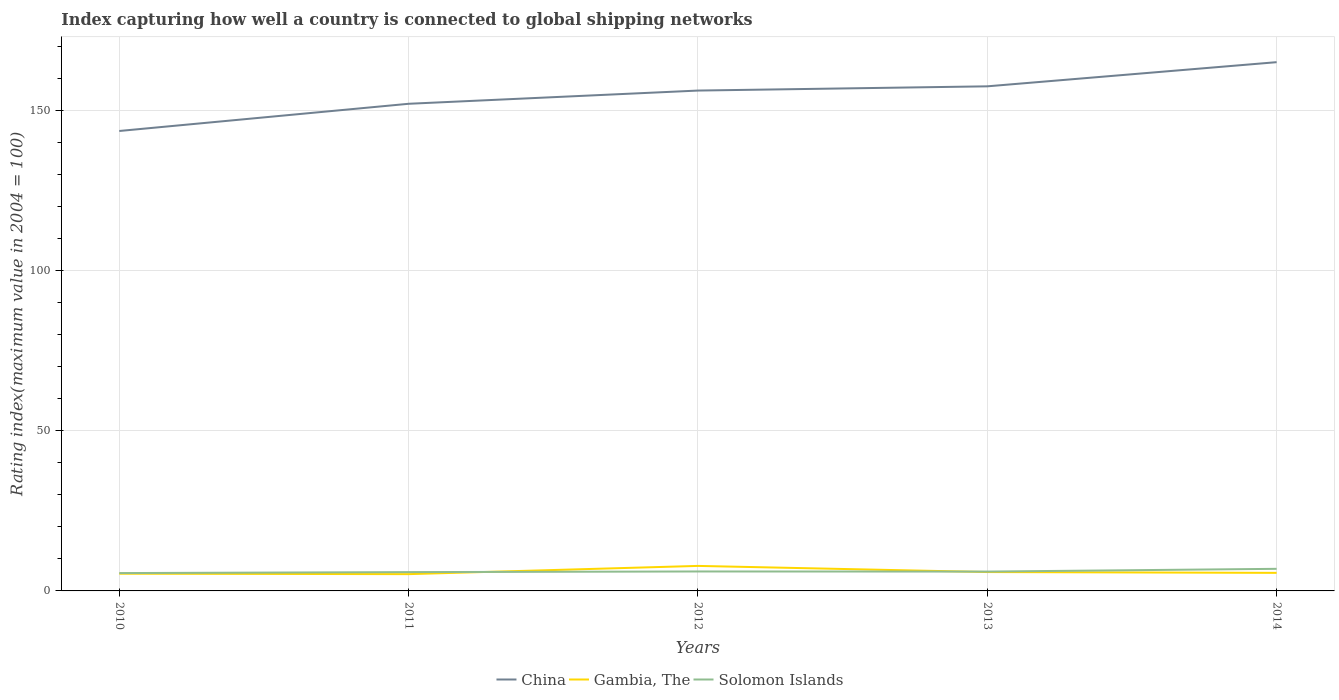How many different coloured lines are there?
Your answer should be very brief. 3. Across all years, what is the maximum rating index in Gambia, The?
Make the answer very short. 5.24. What is the total rating index in China in the graph?
Keep it short and to the point. -13.94. What is the difference between the highest and the second highest rating index in Gambia, The?
Provide a short and direct response. 2.57. Is the rating index in Solomon Islands strictly greater than the rating index in China over the years?
Your answer should be compact. Yes. How many lines are there?
Keep it short and to the point. 3. What is the difference between two consecutive major ticks on the Y-axis?
Make the answer very short. 50. Where does the legend appear in the graph?
Offer a very short reply. Bottom center. How many legend labels are there?
Give a very brief answer. 3. How are the legend labels stacked?
Your answer should be very brief. Horizontal. What is the title of the graph?
Make the answer very short. Index capturing how well a country is connected to global shipping networks. What is the label or title of the X-axis?
Make the answer very short. Years. What is the label or title of the Y-axis?
Keep it short and to the point. Rating index(maximum value in 2004 = 100). What is the Rating index(maximum value in 2004 = 100) of China in 2010?
Keep it short and to the point. 143.57. What is the Rating index(maximum value in 2004 = 100) in Gambia, The in 2010?
Your response must be concise. 5.38. What is the Rating index(maximum value in 2004 = 100) in Solomon Islands in 2010?
Ensure brevity in your answer.  5.57. What is the Rating index(maximum value in 2004 = 100) in China in 2011?
Your answer should be very brief. 152.06. What is the Rating index(maximum value in 2004 = 100) in Gambia, The in 2011?
Provide a succinct answer. 5.24. What is the Rating index(maximum value in 2004 = 100) in Solomon Islands in 2011?
Keep it short and to the point. 5.87. What is the Rating index(maximum value in 2004 = 100) of China in 2012?
Give a very brief answer. 156.19. What is the Rating index(maximum value in 2004 = 100) of Gambia, The in 2012?
Keep it short and to the point. 7.81. What is the Rating index(maximum value in 2004 = 100) in Solomon Islands in 2012?
Your answer should be compact. 6.07. What is the Rating index(maximum value in 2004 = 100) in China in 2013?
Your answer should be very brief. 157.51. What is the Rating index(maximum value in 2004 = 100) of Gambia, The in 2013?
Provide a short and direct response. 5.89. What is the Rating index(maximum value in 2004 = 100) in Solomon Islands in 2013?
Ensure brevity in your answer.  6.04. What is the Rating index(maximum value in 2004 = 100) of China in 2014?
Make the answer very short. 165.05. What is the Rating index(maximum value in 2004 = 100) in Gambia, The in 2014?
Keep it short and to the point. 5.64. What is the Rating index(maximum value in 2004 = 100) in Solomon Islands in 2014?
Make the answer very short. 6.9. Across all years, what is the maximum Rating index(maximum value in 2004 = 100) in China?
Ensure brevity in your answer.  165.05. Across all years, what is the maximum Rating index(maximum value in 2004 = 100) of Gambia, The?
Offer a terse response. 7.81. Across all years, what is the maximum Rating index(maximum value in 2004 = 100) in Solomon Islands?
Offer a very short reply. 6.9. Across all years, what is the minimum Rating index(maximum value in 2004 = 100) of China?
Provide a short and direct response. 143.57. Across all years, what is the minimum Rating index(maximum value in 2004 = 100) of Gambia, The?
Offer a terse response. 5.24. Across all years, what is the minimum Rating index(maximum value in 2004 = 100) of Solomon Islands?
Keep it short and to the point. 5.57. What is the total Rating index(maximum value in 2004 = 100) in China in the graph?
Your answer should be compact. 774.38. What is the total Rating index(maximum value in 2004 = 100) in Gambia, The in the graph?
Give a very brief answer. 29.96. What is the total Rating index(maximum value in 2004 = 100) of Solomon Islands in the graph?
Provide a short and direct response. 30.45. What is the difference between the Rating index(maximum value in 2004 = 100) of China in 2010 and that in 2011?
Offer a terse response. -8.49. What is the difference between the Rating index(maximum value in 2004 = 100) of Gambia, The in 2010 and that in 2011?
Provide a short and direct response. 0.14. What is the difference between the Rating index(maximum value in 2004 = 100) of China in 2010 and that in 2012?
Offer a very short reply. -12.62. What is the difference between the Rating index(maximum value in 2004 = 100) of Gambia, The in 2010 and that in 2012?
Your answer should be compact. -2.43. What is the difference between the Rating index(maximum value in 2004 = 100) of Solomon Islands in 2010 and that in 2012?
Make the answer very short. -0.5. What is the difference between the Rating index(maximum value in 2004 = 100) in China in 2010 and that in 2013?
Make the answer very short. -13.94. What is the difference between the Rating index(maximum value in 2004 = 100) of Gambia, The in 2010 and that in 2013?
Provide a short and direct response. -0.51. What is the difference between the Rating index(maximum value in 2004 = 100) of Solomon Islands in 2010 and that in 2013?
Provide a short and direct response. -0.47. What is the difference between the Rating index(maximum value in 2004 = 100) of China in 2010 and that in 2014?
Offer a terse response. -21.48. What is the difference between the Rating index(maximum value in 2004 = 100) in Gambia, The in 2010 and that in 2014?
Provide a short and direct response. -0.26. What is the difference between the Rating index(maximum value in 2004 = 100) in Solomon Islands in 2010 and that in 2014?
Give a very brief answer. -1.33. What is the difference between the Rating index(maximum value in 2004 = 100) in China in 2011 and that in 2012?
Your answer should be very brief. -4.13. What is the difference between the Rating index(maximum value in 2004 = 100) in Gambia, The in 2011 and that in 2012?
Your response must be concise. -2.57. What is the difference between the Rating index(maximum value in 2004 = 100) of China in 2011 and that in 2013?
Offer a terse response. -5.45. What is the difference between the Rating index(maximum value in 2004 = 100) in Gambia, The in 2011 and that in 2013?
Provide a short and direct response. -0.65. What is the difference between the Rating index(maximum value in 2004 = 100) in Solomon Islands in 2011 and that in 2013?
Your answer should be compact. -0.17. What is the difference between the Rating index(maximum value in 2004 = 100) of China in 2011 and that in 2014?
Make the answer very short. -12.99. What is the difference between the Rating index(maximum value in 2004 = 100) of Gambia, The in 2011 and that in 2014?
Ensure brevity in your answer.  -0.4. What is the difference between the Rating index(maximum value in 2004 = 100) of Solomon Islands in 2011 and that in 2014?
Give a very brief answer. -1.03. What is the difference between the Rating index(maximum value in 2004 = 100) of China in 2012 and that in 2013?
Provide a succinct answer. -1.32. What is the difference between the Rating index(maximum value in 2004 = 100) of Gambia, The in 2012 and that in 2013?
Offer a terse response. 1.92. What is the difference between the Rating index(maximum value in 2004 = 100) in China in 2012 and that in 2014?
Give a very brief answer. -8.86. What is the difference between the Rating index(maximum value in 2004 = 100) in Gambia, The in 2012 and that in 2014?
Your answer should be very brief. 2.17. What is the difference between the Rating index(maximum value in 2004 = 100) in Solomon Islands in 2012 and that in 2014?
Provide a succinct answer. -0.83. What is the difference between the Rating index(maximum value in 2004 = 100) of China in 2013 and that in 2014?
Give a very brief answer. -7.54. What is the difference between the Rating index(maximum value in 2004 = 100) in Gambia, The in 2013 and that in 2014?
Offer a very short reply. 0.25. What is the difference between the Rating index(maximum value in 2004 = 100) in Solomon Islands in 2013 and that in 2014?
Offer a very short reply. -0.86. What is the difference between the Rating index(maximum value in 2004 = 100) of China in 2010 and the Rating index(maximum value in 2004 = 100) of Gambia, The in 2011?
Your response must be concise. 138.33. What is the difference between the Rating index(maximum value in 2004 = 100) in China in 2010 and the Rating index(maximum value in 2004 = 100) in Solomon Islands in 2011?
Give a very brief answer. 137.7. What is the difference between the Rating index(maximum value in 2004 = 100) in Gambia, The in 2010 and the Rating index(maximum value in 2004 = 100) in Solomon Islands in 2011?
Your answer should be very brief. -0.49. What is the difference between the Rating index(maximum value in 2004 = 100) of China in 2010 and the Rating index(maximum value in 2004 = 100) of Gambia, The in 2012?
Offer a very short reply. 135.76. What is the difference between the Rating index(maximum value in 2004 = 100) of China in 2010 and the Rating index(maximum value in 2004 = 100) of Solomon Islands in 2012?
Offer a terse response. 137.5. What is the difference between the Rating index(maximum value in 2004 = 100) of Gambia, The in 2010 and the Rating index(maximum value in 2004 = 100) of Solomon Islands in 2012?
Provide a succinct answer. -0.69. What is the difference between the Rating index(maximum value in 2004 = 100) in China in 2010 and the Rating index(maximum value in 2004 = 100) in Gambia, The in 2013?
Ensure brevity in your answer.  137.68. What is the difference between the Rating index(maximum value in 2004 = 100) of China in 2010 and the Rating index(maximum value in 2004 = 100) of Solomon Islands in 2013?
Give a very brief answer. 137.53. What is the difference between the Rating index(maximum value in 2004 = 100) in Gambia, The in 2010 and the Rating index(maximum value in 2004 = 100) in Solomon Islands in 2013?
Your response must be concise. -0.66. What is the difference between the Rating index(maximum value in 2004 = 100) in China in 2010 and the Rating index(maximum value in 2004 = 100) in Gambia, The in 2014?
Your answer should be very brief. 137.93. What is the difference between the Rating index(maximum value in 2004 = 100) of China in 2010 and the Rating index(maximum value in 2004 = 100) of Solomon Islands in 2014?
Ensure brevity in your answer.  136.67. What is the difference between the Rating index(maximum value in 2004 = 100) in Gambia, The in 2010 and the Rating index(maximum value in 2004 = 100) in Solomon Islands in 2014?
Your response must be concise. -1.52. What is the difference between the Rating index(maximum value in 2004 = 100) in China in 2011 and the Rating index(maximum value in 2004 = 100) in Gambia, The in 2012?
Your answer should be compact. 144.25. What is the difference between the Rating index(maximum value in 2004 = 100) in China in 2011 and the Rating index(maximum value in 2004 = 100) in Solomon Islands in 2012?
Offer a very short reply. 145.99. What is the difference between the Rating index(maximum value in 2004 = 100) of Gambia, The in 2011 and the Rating index(maximum value in 2004 = 100) of Solomon Islands in 2012?
Ensure brevity in your answer.  -0.83. What is the difference between the Rating index(maximum value in 2004 = 100) of China in 2011 and the Rating index(maximum value in 2004 = 100) of Gambia, The in 2013?
Offer a very short reply. 146.17. What is the difference between the Rating index(maximum value in 2004 = 100) in China in 2011 and the Rating index(maximum value in 2004 = 100) in Solomon Islands in 2013?
Offer a very short reply. 146.02. What is the difference between the Rating index(maximum value in 2004 = 100) of Gambia, The in 2011 and the Rating index(maximum value in 2004 = 100) of Solomon Islands in 2013?
Offer a terse response. -0.8. What is the difference between the Rating index(maximum value in 2004 = 100) of China in 2011 and the Rating index(maximum value in 2004 = 100) of Gambia, The in 2014?
Offer a very short reply. 146.42. What is the difference between the Rating index(maximum value in 2004 = 100) in China in 2011 and the Rating index(maximum value in 2004 = 100) in Solomon Islands in 2014?
Make the answer very short. 145.16. What is the difference between the Rating index(maximum value in 2004 = 100) in Gambia, The in 2011 and the Rating index(maximum value in 2004 = 100) in Solomon Islands in 2014?
Make the answer very short. -1.66. What is the difference between the Rating index(maximum value in 2004 = 100) in China in 2012 and the Rating index(maximum value in 2004 = 100) in Gambia, The in 2013?
Provide a short and direct response. 150.3. What is the difference between the Rating index(maximum value in 2004 = 100) of China in 2012 and the Rating index(maximum value in 2004 = 100) of Solomon Islands in 2013?
Offer a terse response. 150.15. What is the difference between the Rating index(maximum value in 2004 = 100) in Gambia, The in 2012 and the Rating index(maximum value in 2004 = 100) in Solomon Islands in 2013?
Keep it short and to the point. 1.77. What is the difference between the Rating index(maximum value in 2004 = 100) in China in 2012 and the Rating index(maximum value in 2004 = 100) in Gambia, The in 2014?
Provide a short and direct response. 150.55. What is the difference between the Rating index(maximum value in 2004 = 100) in China in 2012 and the Rating index(maximum value in 2004 = 100) in Solomon Islands in 2014?
Keep it short and to the point. 149.29. What is the difference between the Rating index(maximum value in 2004 = 100) in Gambia, The in 2012 and the Rating index(maximum value in 2004 = 100) in Solomon Islands in 2014?
Your response must be concise. 0.91. What is the difference between the Rating index(maximum value in 2004 = 100) in China in 2013 and the Rating index(maximum value in 2004 = 100) in Gambia, The in 2014?
Provide a short and direct response. 151.87. What is the difference between the Rating index(maximum value in 2004 = 100) of China in 2013 and the Rating index(maximum value in 2004 = 100) of Solomon Islands in 2014?
Offer a terse response. 150.61. What is the difference between the Rating index(maximum value in 2004 = 100) in Gambia, The in 2013 and the Rating index(maximum value in 2004 = 100) in Solomon Islands in 2014?
Make the answer very short. -1.01. What is the average Rating index(maximum value in 2004 = 100) in China per year?
Keep it short and to the point. 154.88. What is the average Rating index(maximum value in 2004 = 100) in Gambia, The per year?
Offer a very short reply. 5.99. What is the average Rating index(maximum value in 2004 = 100) of Solomon Islands per year?
Provide a succinct answer. 6.09. In the year 2010, what is the difference between the Rating index(maximum value in 2004 = 100) of China and Rating index(maximum value in 2004 = 100) of Gambia, The?
Ensure brevity in your answer.  138.19. In the year 2010, what is the difference between the Rating index(maximum value in 2004 = 100) in China and Rating index(maximum value in 2004 = 100) in Solomon Islands?
Make the answer very short. 138. In the year 2010, what is the difference between the Rating index(maximum value in 2004 = 100) of Gambia, The and Rating index(maximum value in 2004 = 100) of Solomon Islands?
Your answer should be very brief. -0.19. In the year 2011, what is the difference between the Rating index(maximum value in 2004 = 100) in China and Rating index(maximum value in 2004 = 100) in Gambia, The?
Your response must be concise. 146.82. In the year 2011, what is the difference between the Rating index(maximum value in 2004 = 100) in China and Rating index(maximum value in 2004 = 100) in Solomon Islands?
Your answer should be very brief. 146.19. In the year 2011, what is the difference between the Rating index(maximum value in 2004 = 100) in Gambia, The and Rating index(maximum value in 2004 = 100) in Solomon Islands?
Keep it short and to the point. -0.63. In the year 2012, what is the difference between the Rating index(maximum value in 2004 = 100) of China and Rating index(maximum value in 2004 = 100) of Gambia, The?
Your answer should be very brief. 148.38. In the year 2012, what is the difference between the Rating index(maximum value in 2004 = 100) of China and Rating index(maximum value in 2004 = 100) of Solomon Islands?
Make the answer very short. 150.12. In the year 2012, what is the difference between the Rating index(maximum value in 2004 = 100) in Gambia, The and Rating index(maximum value in 2004 = 100) in Solomon Islands?
Provide a short and direct response. 1.74. In the year 2013, what is the difference between the Rating index(maximum value in 2004 = 100) in China and Rating index(maximum value in 2004 = 100) in Gambia, The?
Make the answer very short. 151.62. In the year 2013, what is the difference between the Rating index(maximum value in 2004 = 100) of China and Rating index(maximum value in 2004 = 100) of Solomon Islands?
Your answer should be compact. 151.47. In the year 2014, what is the difference between the Rating index(maximum value in 2004 = 100) in China and Rating index(maximum value in 2004 = 100) in Gambia, The?
Provide a short and direct response. 159.41. In the year 2014, what is the difference between the Rating index(maximum value in 2004 = 100) in China and Rating index(maximum value in 2004 = 100) in Solomon Islands?
Your answer should be compact. 158.15. In the year 2014, what is the difference between the Rating index(maximum value in 2004 = 100) of Gambia, The and Rating index(maximum value in 2004 = 100) of Solomon Islands?
Provide a succinct answer. -1.26. What is the ratio of the Rating index(maximum value in 2004 = 100) in China in 2010 to that in 2011?
Offer a terse response. 0.94. What is the ratio of the Rating index(maximum value in 2004 = 100) of Gambia, The in 2010 to that in 2011?
Ensure brevity in your answer.  1.03. What is the ratio of the Rating index(maximum value in 2004 = 100) in Solomon Islands in 2010 to that in 2011?
Your response must be concise. 0.95. What is the ratio of the Rating index(maximum value in 2004 = 100) of China in 2010 to that in 2012?
Give a very brief answer. 0.92. What is the ratio of the Rating index(maximum value in 2004 = 100) in Gambia, The in 2010 to that in 2012?
Your response must be concise. 0.69. What is the ratio of the Rating index(maximum value in 2004 = 100) of Solomon Islands in 2010 to that in 2012?
Your answer should be compact. 0.92. What is the ratio of the Rating index(maximum value in 2004 = 100) of China in 2010 to that in 2013?
Provide a short and direct response. 0.91. What is the ratio of the Rating index(maximum value in 2004 = 100) of Gambia, The in 2010 to that in 2013?
Provide a short and direct response. 0.91. What is the ratio of the Rating index(maximum value in 2004 = 100) of Solomon Islands in 2010 to that in 2013?
Provide a succinct answer. 0.92. What is the ratio of the Rating index(maximum value in 2004 = 100) of China in 2010 to that in 2014?
Your response must be concise. 0.87. What is the ratio of the Rating index(maximum value in 2004 = 100) in Gambia, The in 2010 to that in 2014?
Your answer should be very brief. 0.95. What is the ratio of the Rating index(maximum value in 2004 = 100) of Solomon Islands in 2010 to that in 2014?
Offer a very short reply. 0.81. What is the ratio of the Rating index(maximum value in 2004 = 100) in China in 2011 to that in 2012?
Your response must be concise. 0.97. What is the ratio of the Rating index(maximum value in 2004 = 100) in Gambia, The in 2011 to that in 2012?
Your answer should be very brief. 0.67. What is the ratio of the Rating index(maximum value in 2004 = 100) of Solomon Islands in 2011 to that in 2012?
Your response must be concise. 0.97. What is the ratio of the Rating index(maximum value in 2004 = 100) of China in 2011 to that in 2013?
Your response must be concise. 0.97. What is the ratio of the Rating index(maximum value in 2004 = 100) in Gambia, The in 2011 to that in 2013?
Provide a short and direct response. 0.89. What is the ratio of the Rating index(maximum value in 2004 = 100) in Solomon Islands in 2011 to that in 2013?
Offer a terse response. 0.97. What is the ratio of the Rating index(maximum value in 2004 = 100) of China in 2011 to that in 2014?
Your answer should be very brief. 0.92. What is the ratio of the Rating index(maximum value in 2004 = 100) of Gambia, The in 2011 to that in 2014?
Keep it short and to the point. 0.93. What is the ratio of the Rating index(maximum value in 2004 = 100) of Solomon Islands in 2011 to that in 2014?
Your answer should be very brief. 0.85. What is the ratio of the Rating index(maximum value in 2004 = 100) in Gambia, The in 2012 to that in 2013?
Your answer should be compact. 1.33. What is the ratio of the Rating index(maximum value in 2004 = 100) of China in 2012 to that in 2014?
Offer a very short reply. 0.95. What is the ratio of the Rating index(maximum value in 2004 = 100) of Gambia, The in 2012 to that in 2014?
Provide a succinct answer. 1.39. What is the ratio of the Rating index(maximum value in 2004 = 100) in Solomon Islands in 2012 to that in 2014?
Ensure brevity in your answer.  0.88. What is the ratio of the Rating index(maximum value in 2004 = 100) in China in 2013 to that in 2014?
Give a very brief answer. 0.95. What is the ratio of the Rating index(maximum value in 2004 = 100) in Gambia, The in 2013 to that in 2014?
Ensure brevity in your answer.  1.04. What is the ratio of the Rating index(maximum value in 2004 = 100) in Solomon Islands in 2013 to that in 2014?
Your response must be concise. 0.88. What is the difference between the highest and the second highest Rating index(maximum value in 2004 = 100) in China?
Your answer should be compact. 7.54. What is the difference between the highest and the second highest Rating index(maximum value in 2004 = 100) in Gambia, The?
Keep it short and to the point. 1.92. What is the difference between the highest and the second highest Rating index(maximum value in 2004 = 100) in Solomon Islands?
Your answer should be compact. 0.83. What is the difference between the highest and the lowest Rating index(maximum value in 2004 = 100) of China?
Your answer should be very brief. 21.48. What is the difference between the highest and the lowest Rating index(maximum value in 2004 = 100) of Gambia, The?
Offer a very short reply. 2.57. What is the difference between the highest and the lowest Rating index(maximum value in 2004 = 100) in Solomon Islands?
Your answer should be compact. 1.33. 